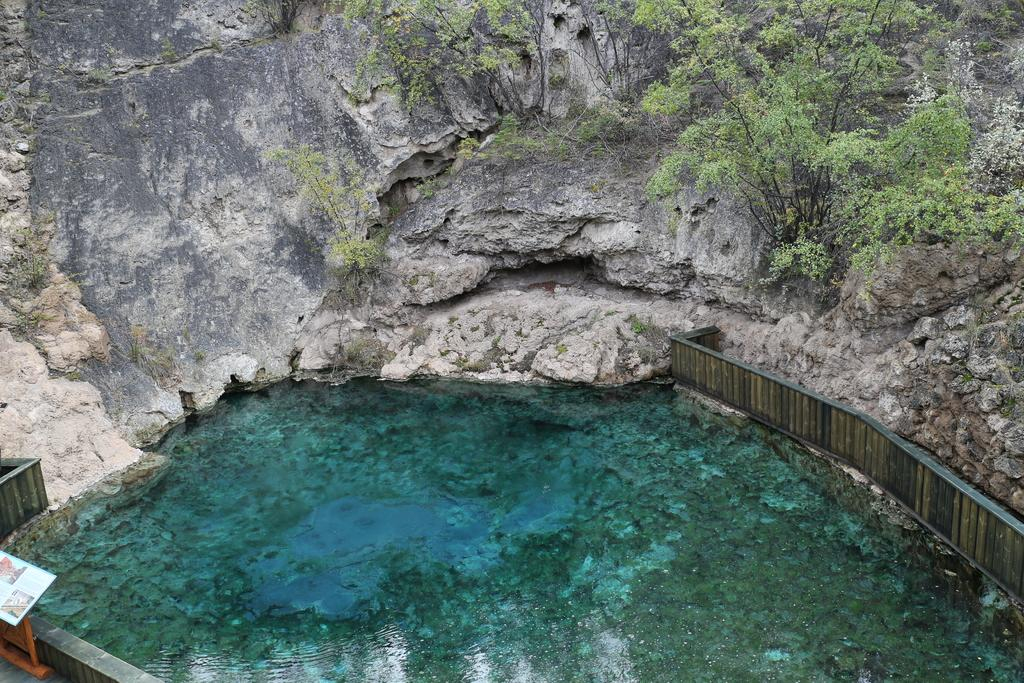What type of natural feature is located on the hill in the image? There are plants on a hill in the image. What body of water is visible at the bottom of the image? There is a lake at the bottom of the image. What can be seen on the left and right sides of the image near the lake? There are barriers in the bottom left and bottom right of the image. What is the tongue's role in the image? There is no tongue present in the image. How is the connection between the hill and the lake established in the image? The image does not depict a direct connection between the hill and the lake; it simply shows them as separate features. 